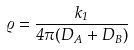<formula> <loc_0><loc_0><loc_500><loc_500>\varrho = \frac { k _ { 1 } } { 4 \pi ( D _ { A } + D _ { B } ) }</formula> 